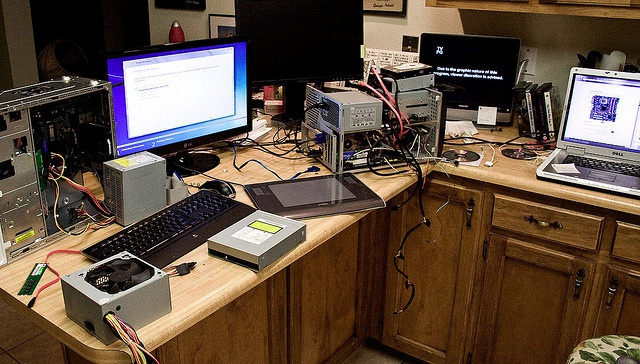Describe the objects in this image and their specific colors. I can see tv in black, white, and blue tones, laptop in black, white, darkgray, and gray tones, keyboard in black, gray, and darkgray tones, keyboard in black, gray, and darkgray tones, and mouse in black, gray, and darkgray tones in this image. 